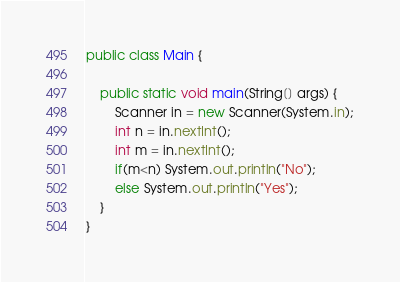Convert code to text. <code><loc_0><loc_0><loc_500><loc_500><_Java_>public class Main {
	
	public static void main(String[] args) {
		Scanner in = new Scanner(System.in);
		int n = in.nextInt();
		int m = in.nextInt();
		if(m<n) System.out.println("No");
		else System.out.println("Yes");
	}
}</code> 